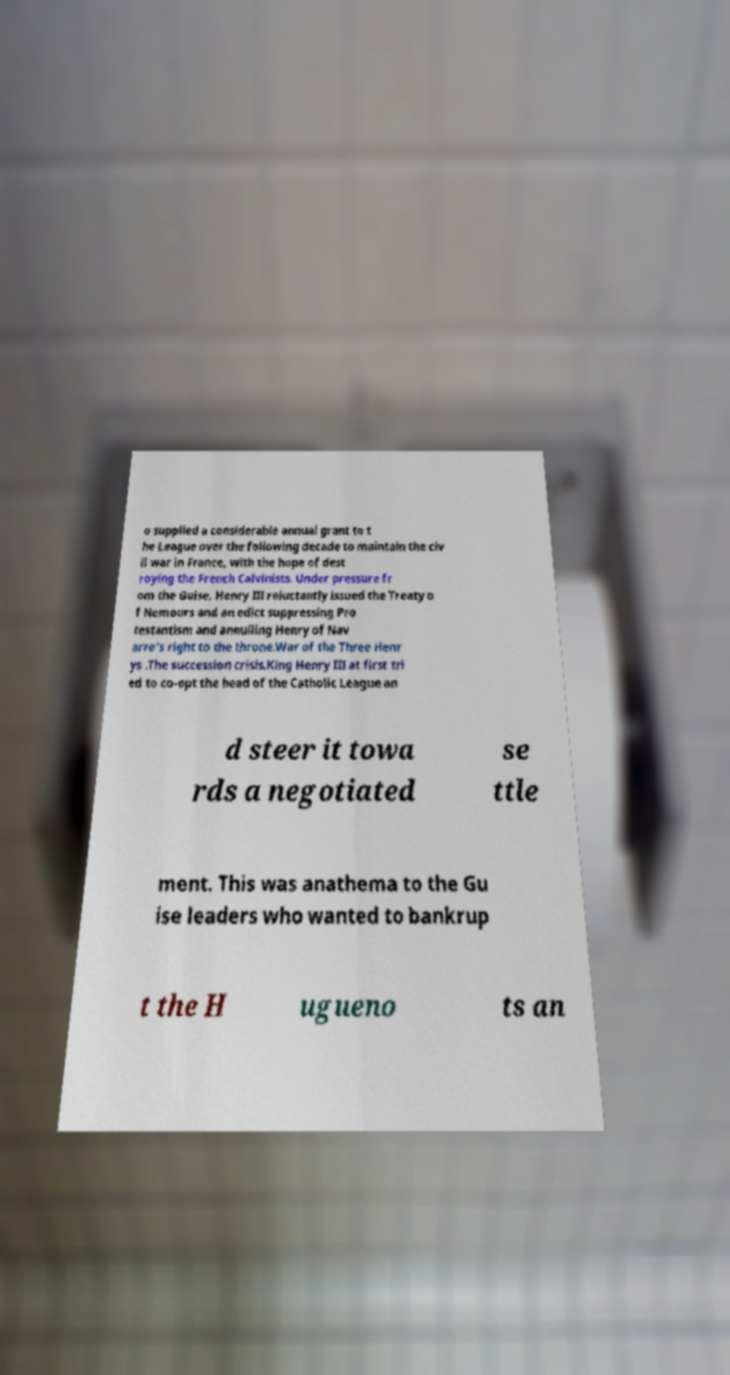Please read and relay the text visible in this image. What does it say? o supplied a considerable annual grant to t he League over the following decade to maintain the civ il war in France, with the hope of dest roying the French Calvinists. Under pressure fr om the Guise, Henry III reluctantly issued the Treaty o f Nemours and an edict suppressing Pro testantism and annulling Henry of Nav arre's right to the throne.War of the Three Henr ys .The succession crisis.King Henry III at first tri ed to co-opt the head of the Catholic League an d steer it towa rds a negotiated se ttle ment. This was anathema to the Gu ise leaders who wanted to bankrup t the H ugueno ts an 